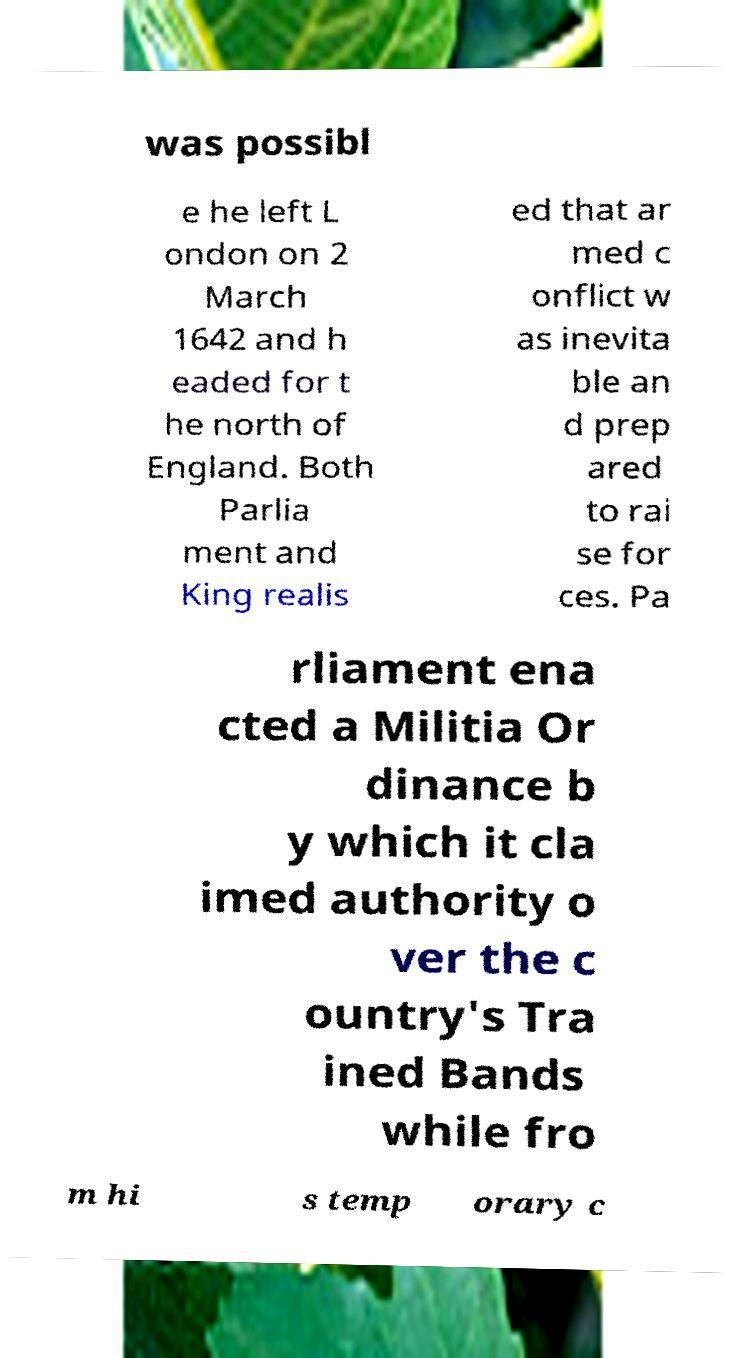Please identify and transcribe the text found in this image. was possibl e he left L ondon on 2 March 1642 and h eaded for t he north of England. Both Parlia ment and King realis ed that ar med c onflict w as inevita ble an d prep ared to rai se for ces. Pa rliament ena cted a Militia Or dinance b y which it cla imed authority o ver the c ountry's Tra ined Bands while fro m hi s temp orary c 